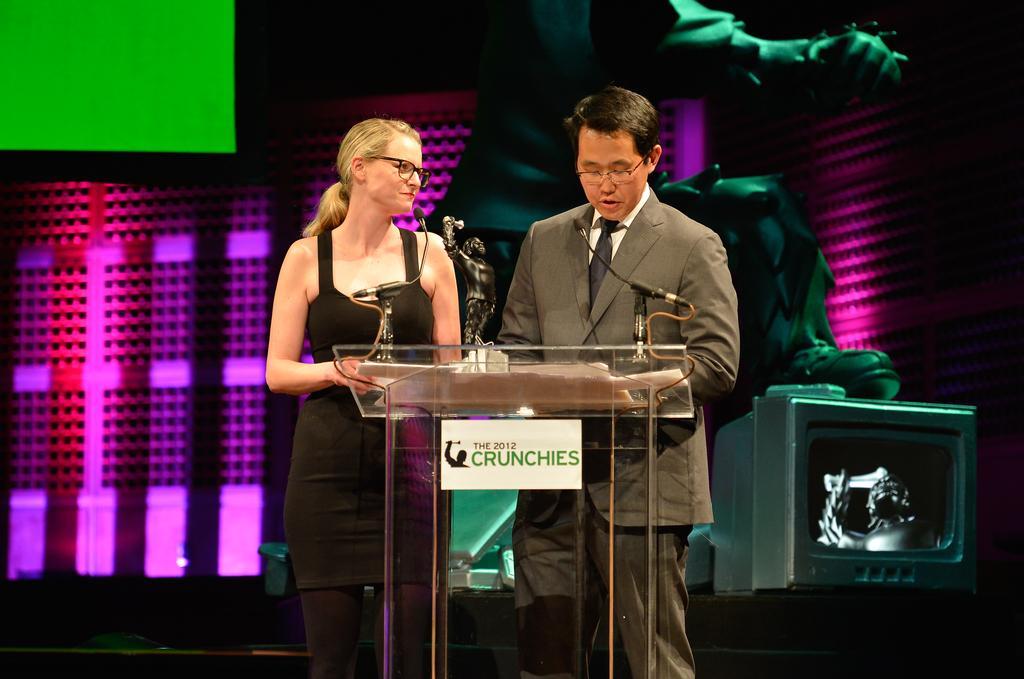In one or two sentences, can you explain what this image depicts? In the picture I can see two persons standing and there is a glass stand in front of them which has two mics and some other objects on it and there is a television,few lights and some other objects in the background. 